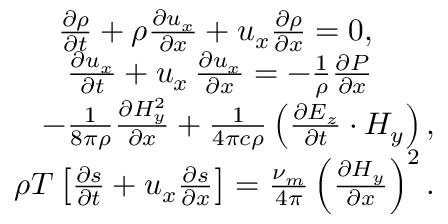<formula> <loc_0><loc_0><loc_500><loc_500>\begin{array} { r } { \frac { \partial \rho } { \partial t } + \rho \frac { \partial { u _ { x } } } { \partial x } + u _ { x } \frac { \partial { \rho } } { \partial x } = 0 , \quad } \\ { \frac { \partial { u _ { x } } } { \partial t } + u _ { x } \, \frac { \partial { u _ { x } } } { \partial x } = - \frac { 1 } { \rho } \frac { \partial { P } } { \partial x } \quad } \\ { - \frac { 1 } { 8 \pi \rho } \frac { \partial { H _ { y } ^ { 2 } } } { \partial x } + \frac { 1 } { 4 \pi c \rho } \left ( \frac { \partial { E _ { z } } } { \partial t } \cdot H _ { y } \right ) , } \\ { \rho T \left [ \frac { \partial { s } } { \partial t } + u _ { x } \frac { \partial { s } } { \partial x } \right ] = \frac { \nu _ { m } } { 4 \pi } \left ( \frac { \partial { H _ { y } } } { \partial x } \right ) ^ { 2 } . } \end{array}</formula> 